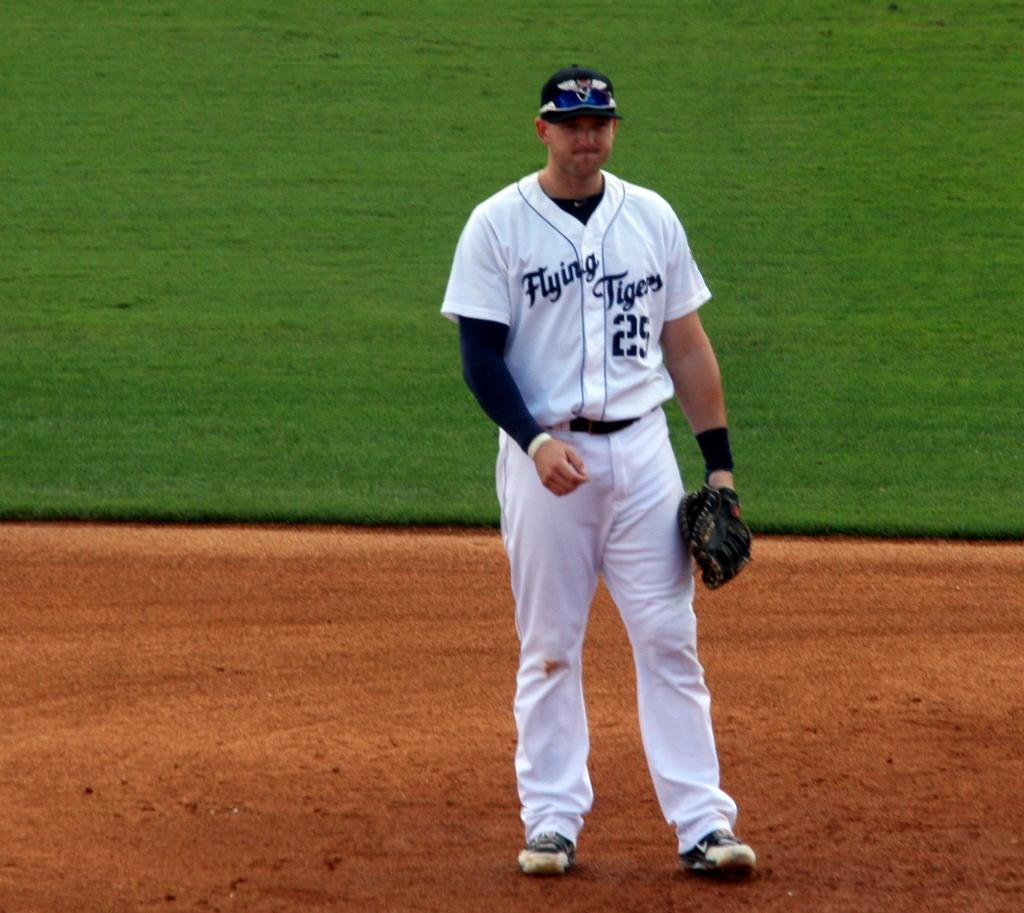<image>
Describe the image concisely. Flying Tigers baseball player #25 stands in the infield with his mitt. 